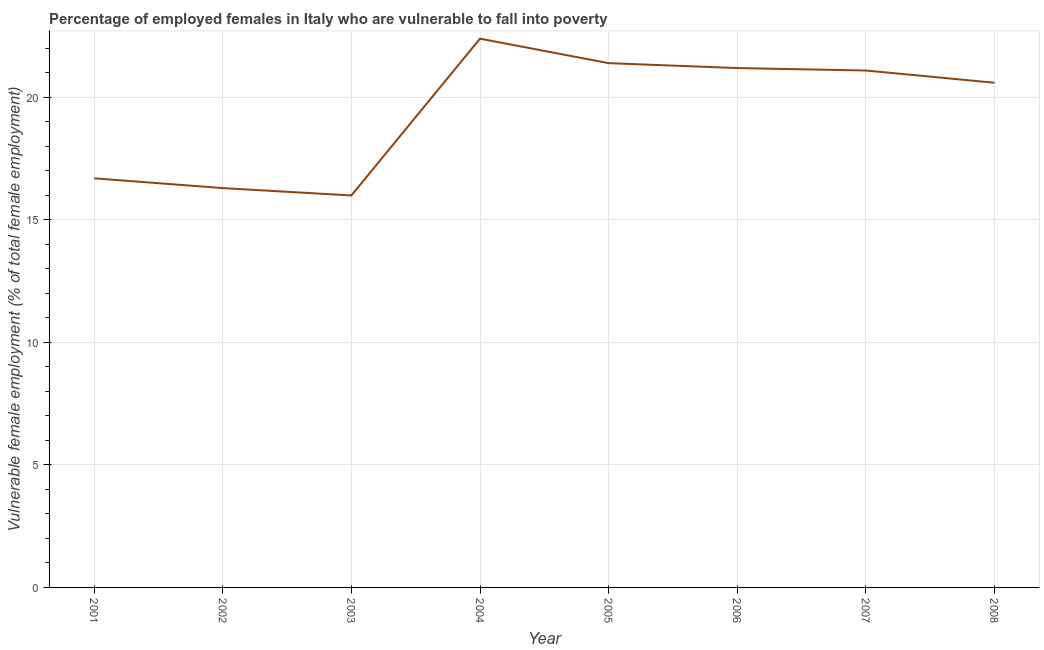What is the percentage of employed females who are vulnerable to fall into poverty in 2005?
Offer a very short reply. 21.4. Across all years, what is the maximum percentage of employed females who are vulnerable to fall into poverty?
Give a very brief answer. 22.4. In which year was the percentage of employed females who are vulnerable to fall into poverty minimum?
Ensure brevity in your answer.  2003. What is the sum of the percentage of employed females who are vulnerable to fall into poverty?
Provide a short and direct response. 155.7. What is the difference between the percentage of employed females who are vulnerable to fall into poverty in 2001 and 2007?
Ensure brevity in your answer.  -4.4. What is the average percentage of employed females who are vulnerable to fall into poverty per year?
Provide a short and direct response. 19.46. What is the median percentage of employed females who are vulnerable to fall into poverty?
Keep it short and to the point. 20.85. Do a majority of the years between 2001 and 2007 (inclusive) have percentage of employed females who are vulnerable to fall into poverty greater than 6 %?
Offer a very short reply. Yes. What is the ratio of the percentage of employed females who are vulnerable to fall into poverty in 2004 to that in 2007?
Make the answer very short. 1.06. Is the difference between the percentage of employed females who are vulnerable to fall into poverty in 2007 and 2008 greater than the difference between any two years?
Make the answer very short. No. What is the difference between the highest and the second highest percentage of employed females who are vulnerable to fall into poverty?
Offer a very short reply. 1. Is the sum of the percentage of employed females who are vulnerable to fall into poverty in 2003 and 2006 greater than the maximum percentage of employed females who are vulnerable to fall into poverty across all years?
Offer a very short reply. Yes. What is the difference between the highest and the lowest percentage of employed females who are vulnerable to fall into poverty?
Offer a very short reply. 6.4. Does the percentage of employed females who are vulnerable to fall into poverty monotonically increase over the years?
Make the answer very short. No. What is the title of the graph?
Keep it short and to the point. Percentage of employed females in Italy who are vulnerable to fall into poverty. What is the label or title of the X-axis?
Offer a very short reply. Year. What is the label or title of the Y-axis?
Provide a short and direct response. Vulnerable female employment (% of total female employment). What is the Vulnerable female employment (% of total female employment) in 2001?
Provide a short and direct response. 16.7. What is the Vulnerable female employment (% of total female employment) of 2002?
Your answer should be very brief. 16.3. What is the Vulnerable female employment (% of total female employment) in 2003?
Provide a succinct answer. 16. What is the Vulnerable female employment (% of total female employment) in 2004?
Make the answer very short. 22.4. What is the Vulnerable female employment (% of total female employment) of 2005?
Give a very brief answer. 21.4. What is the Vulnerable female employment (% of total female employment) in 2006?
Your response must be concise. 21.2. What is the Vulnerable female employment (% of total female employment) in 2007?
Give a very brief answer. 21.1. What is the Vulnerable female employment (% of total female employment) of 2008?
Your answer should be compact. 20.6. What is the difference between the Vulnerable female employment (% of total female employment) in 2001 and 2002?
Give a very brief answer. 0.4. What is the difference between the Vulnerable female employment (% of total female employment) in 2001 and 2004?
Make the answer very short. -5.7. What is the difference between the Vulnerable female employment (% of total female employment) in 2001 and 2005?
Provide a succinct answer. -4.7. What is the difference between the Vulnerable female employment (% of total female employment) in 2001 and 2006?
Your response must be concise. -4.5. What is the difference between the Vulnerable female employment (% of total female employment) in 2001 and 2007?
Your answer should be very brief. -4.4. What is the difference between the Vulnerable female employment (% of total female employment) in 2002 and 2006?
Offer a very short reply. -4.9. What is the difference between the Vulnerable female employment (% of total female employment) in 2002 and 2008?
Offer a terse response. -4.3. What is the difference between the Vulnerable female employment (% of total female employment) in 2003 and 2005?
Ensure brevity in your answer.  -5.4. What is the difference between the Vulnerable female employment (% of total female employment) in 2003 and 2006?
Ensure brevity in your answer.  -5.2. What is the difference between the Vulnerable female employment (% of total female employment) in 2003 and 2008?
Offer a very short reply. -4.6. What is the difference between the Vulnerable female employment (% of total female employment) in 2004 and 2005?
Your answer should be very brief. 1. What is the difference between the Vulnerable female employment (% of total female employment) in 2004 and 2006?
Offer a very short reply. 1.2. What is the difference between the Vulnerable female employment (% of total female employment) in 2005 and 2006?
Provide a short and direct response. 0.2. What is the difference between the Vulnerable female employment (% of total female employment) in 2005 and 2007?
Your answer should be compact. 0.3. What is the difference between the Vulnerable female employment (% of total female employment) in 2006 and 2007?
Provide a short and direct response. 0.1. What is the difference between the Vulnerable female employment (% of total female employment) in 2006 and 2008?
Your answer should be compact. 0.6. What is the difference between the Vulnerable female employment (% of total female employment) in 2007 and 2008?
Provide a succinct answer. 0.5. What is the ratio of the Vulnerable female employment (% of total female employment) in 2001 to that in 2002?
Provide a succinct answer. 1.02. What is the ratio of the Vulnerable female employment (% of total female employment) in 2001 to that in 2003?
Your answer should be compact. 1.04. What is the ratio of the Vulnerable female employment (% of total female employment) in 2001 to that in 2004?
Your answer should be very brief. 0.75. What is the ratio of the Vulnerable female employment (% of total female employment) in 2001 to that in 2005?
Give a very brief answer. 0.78. What is the ratio of the Vulnerable female employment (% of total female employment) in 2001 to that in 2006?
Provide a succinct answer. 0.79. What is the ratio of the Vulnerable female employment (% of total female employment) in 2001 to that in 2007?
Keep it short and to the point. 0.79. What is the ratio of the Vulnerable female employment (% of total female employment) in 2001 to that in 2008?
Ensure brevity in your answer.  0.81. What is the ratio of the Vulnerable female employment (% of total female employment) in 2002 to that in 2003?
Provide a succinct answer. 1.02. What is the ratio of the Vulnerable female employment (% of total female employment) in 2002 to that in 2004?
Provide a short and direct response. 0.73. What is the ratio of the Vulnerable female employment (% of total female employment) in 2002 to that in 2005?
Your answer should be very brief. 0.76. What is the ratio of the Vulnerable female employment (% of total female employment) in 2002 to that in 2006?
Provide a short and direct response. 0.77. What is the ratio of the Vulnerable female employment (% of total female employment) in 2002 to that in 2007?
Your response must be concise. 0.77. What is the ratio of the Vulnerable female employment (% of total female employment) in 2002 to that in 2008?
Offer a terse response. 0.79. What is the ratio of the Vulnerable female employment (% of total female employment) in 2003 to that in 2004?
Provide a short and direct response. 0.71. What is the ratio of the Vulnerable female employment (% of total female employment) in 2003 to that in 2005?
Provide a short and direct response. 0.75. What is the ratio of the Vulnerable female employment (% of total female employment) in 2003 to that in 2006?
Give a very brief answer. 0.76. What is the ratio of the Vulnerable female employment (% of total female employment) in 2003 to that in 2007?
Provide a short and direct response. 0.76. What is the ratio of the Vulnerable female employment (% of total female employment) in 2003 to that in 2008?
Give a very brief answer. 0.78. What is the ratio of the Vulnerable female employment (% of total female employment) in 2004 to that in 2005?
Offer a very short reply. 1.05. What is the ratio of the Vulnerable female employment (% of total female employment) in 2004 to that in 2006?
Provide a succinct answer. 1.06. What is the ratio of the Vulnerable female employment (% of total female employment) in 2004 to that in 2007?
Ensure brevity in your answer.  1.06. What is the ratio of the Vulnerable female employment (% of total female employment) in 2004 to that in 2008?
Offer a very short reply. 1.09. What is the ratio of the Vulnerable female employment (% of total female employment) in 2005 to that in 2008?
Give a very brief answer. 1.04. What is the ratio of the Vulnerable female employment (% of total female employment) in 2006 to that in 2007?
Make the answer very short. 1. What is the ratio of the Vulnerable female employment (% of total female employment) in 2006 to that in 2008?
Give a very brief answer. 1.03. What is the ratio of the Vulnerable female employment (% of total female employment) in 2007 to that in 2008?
Provide a short and direct response. 1.02. 